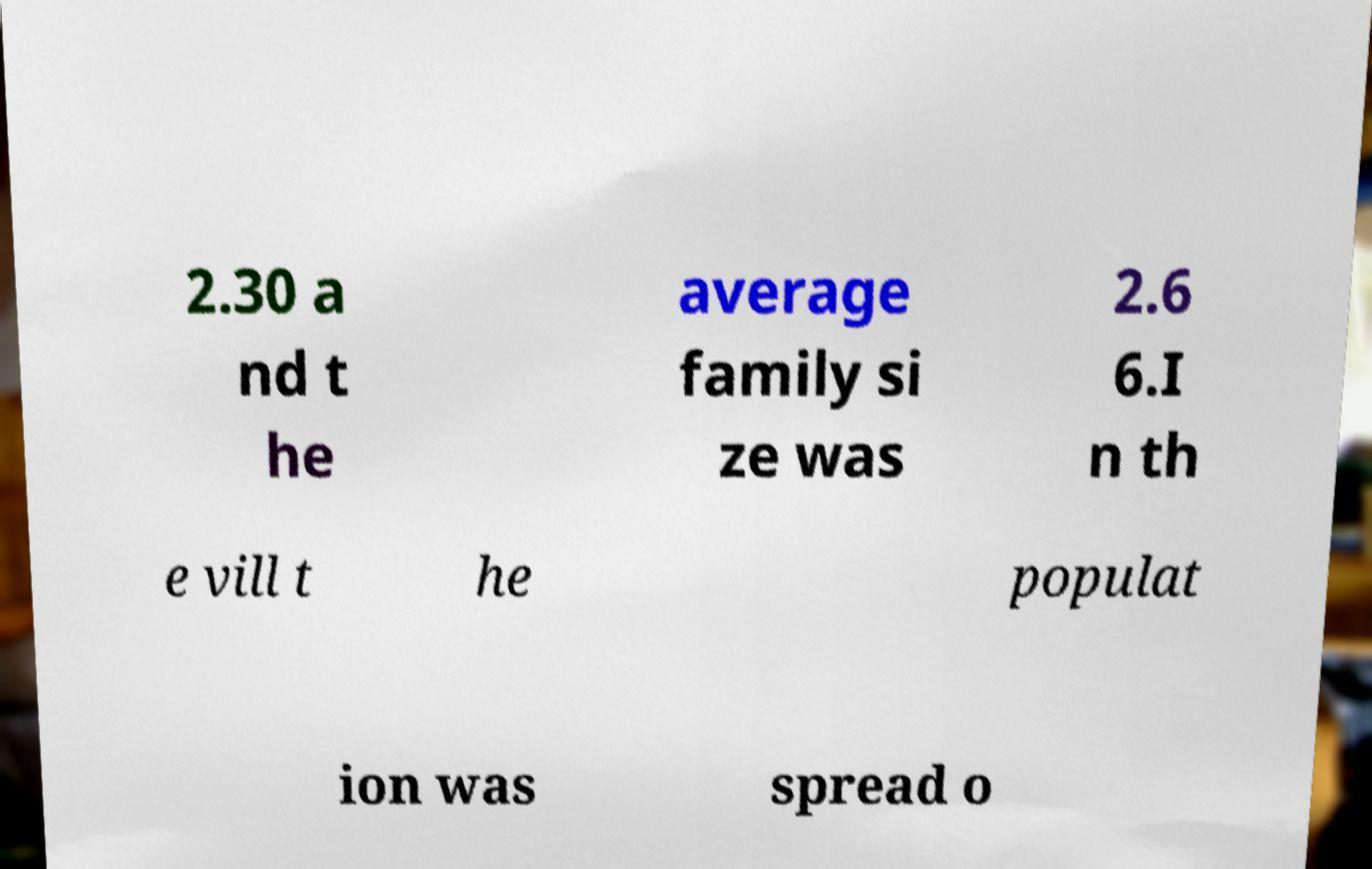Can you read and provide the text displayed in the image?This photo seems to have some interesting text. Can you extract and type it out for me? 2.30 a nd t he average family si ze was 2.6 6.I n th e vill t he populat ion was spread o 